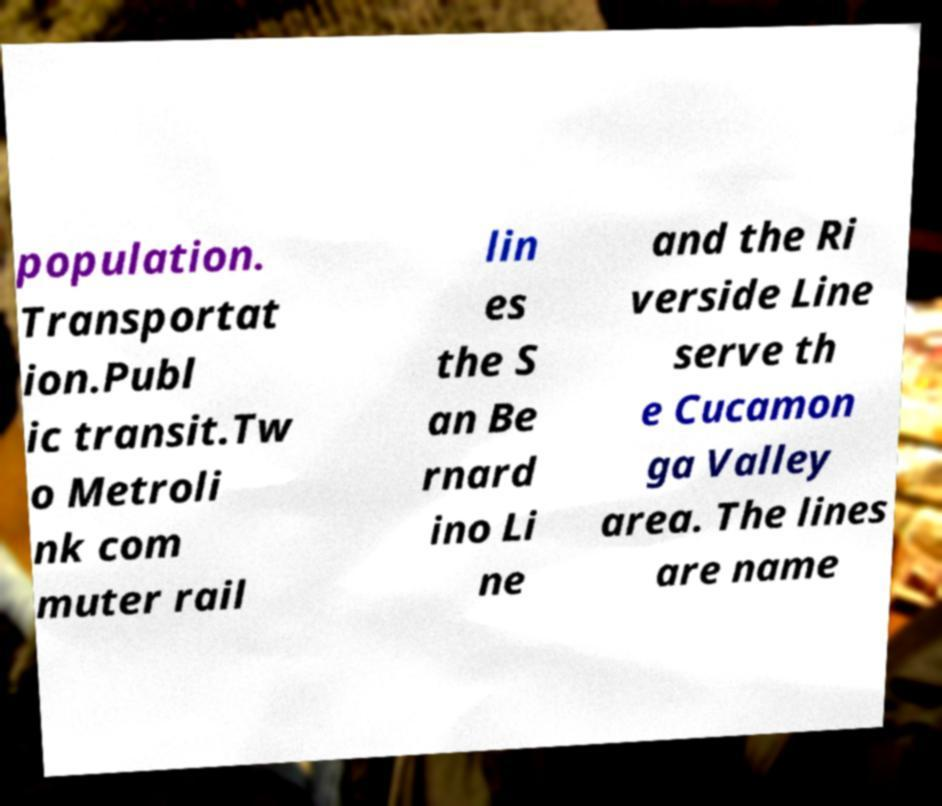Could you assist in decoding the text presented in this image and type it out clearly? population. Transportat ion.Publ ic transit.Tw o Metroli nk com muter rail lin es the S an Be rnard ino Li ne and the Ri verside Line serve th e Cucamon ga Valley area. The lines are name 